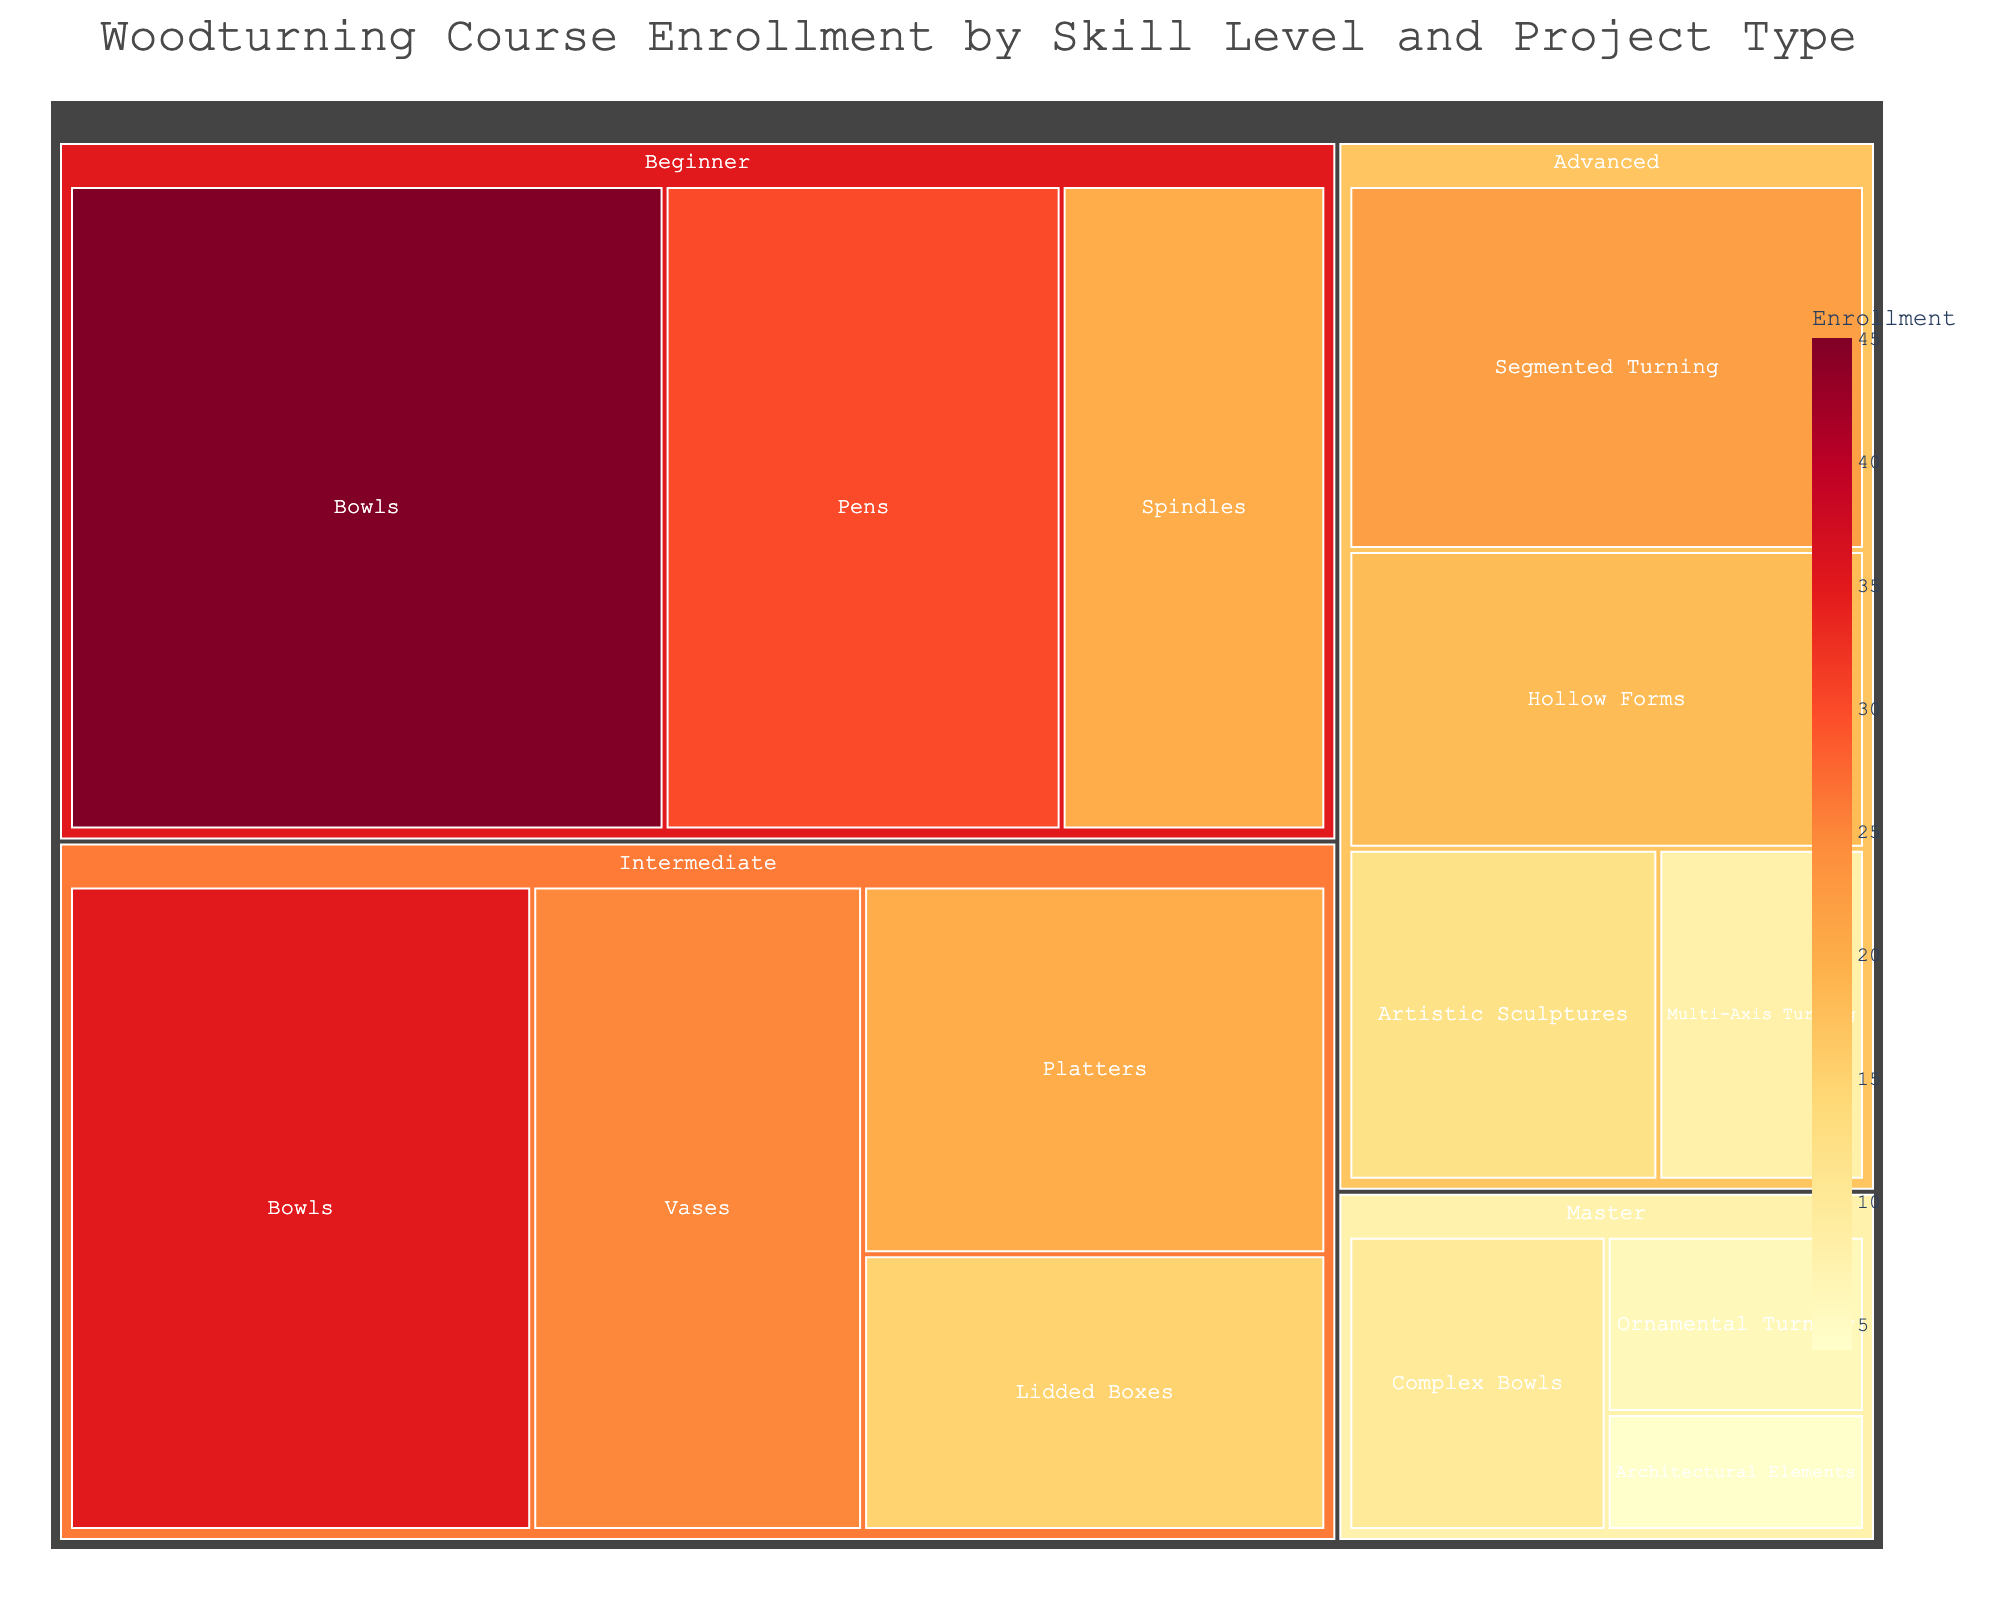what is the title of the treemap? The title of a figure is usually located at the top and provides a summary of the content. It says 'Woodturning Course Enrollment by Skill Level and Project Type'.
Answer: Woodturning Course Enrollment by Skill Level and Project Type what skill level has the highest enrollment count for bowls? We need to look at the "Bowls" projects and compare the enrollment counts across different skill levels. The beginner level has the highest count with 45 enrollments.
Answer: Beginner what is the total enrollment count for intermediate level? Sum the enrollments for intermediate projects: Bowls (35) + Vases (25) + Platters (20) + Lidded Boxes (15). So, 35 + 25 + 20 + 15 = 95.
Answer: 95 how does the enrollment count for advanced segmented turning compare to artistic sculptures? Look at the advanced level section and compare the numbers for "Segmented Turning" (22) and "Artistic Sculptures" (12). Segmented Turning has a higher enrollment.
Answer: Segmented Turning has higher enrollment which project type has more enrollments: beginner pens or intermediate vases? Compare the enrollment counts for "Beginner Pens" (30) and "Intermediate Vases" (25). 30 is greater than 25, so beginner pens have more enrollments.
Answer: Beginner Pens is the enrollment for master complex bowls greater than advanced multi-axis turning? Look at the enrollment counts for "Master Complex Bowls" (10) and "Advanced Multi-Axis Turning" (8). 10 is greater than 8.
Answer: Yes which skill level has the lowest overall enrollment count? Add up the enrollments for each skill level. Master has the lowest counts: Complex Bowls (10) + Ornamental Turning (6) + Architectural Elements (4) = 20.
Answer: Master which project type has the highest enrollment count in the treemap? Visually locate the largest segment in the treemap with the highest numeric value. Beginner Bowls have the highest enrollment count of 45.
Answer: Bowls in Beginner what percentage of total enrollment does advanced hollow forms represent? First, find total enrollments: 45+30+20+35+25+20+15+18+22+12+8+10+6+4 = 270. The percentage is (18/270) * 100. So, it's approximately 6.67%.
Answer: ~6.67% what is the difference in enrollment count between beginner spindles and intermediate lidded boxes? Compare enrollment counts for "Beginner Spindles" (20) and "Intermediate Lidded Boxes" (15). The difference is 20 - 15 = 5.
Answer: 5 